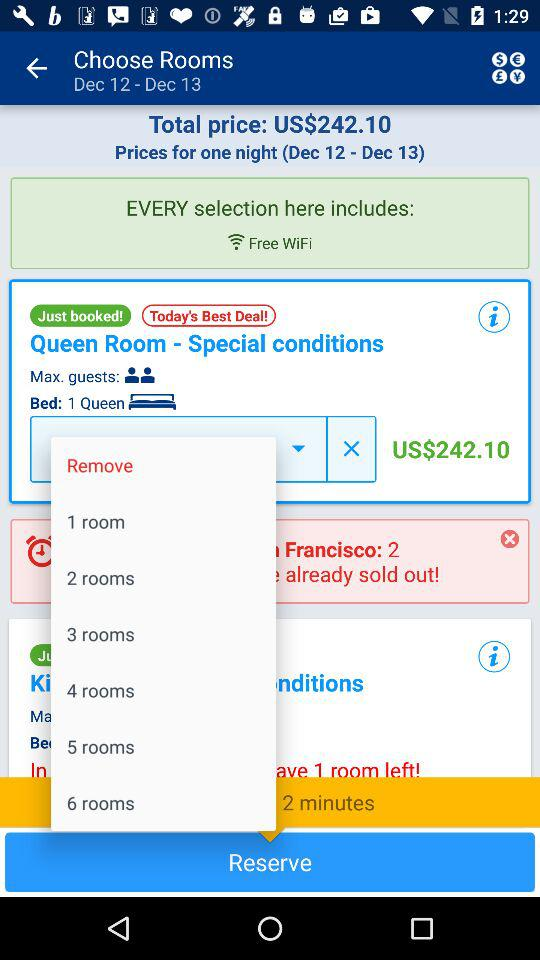How much is the total price of the reservation?
Answer the question using a single word or phrase. US$242.10 